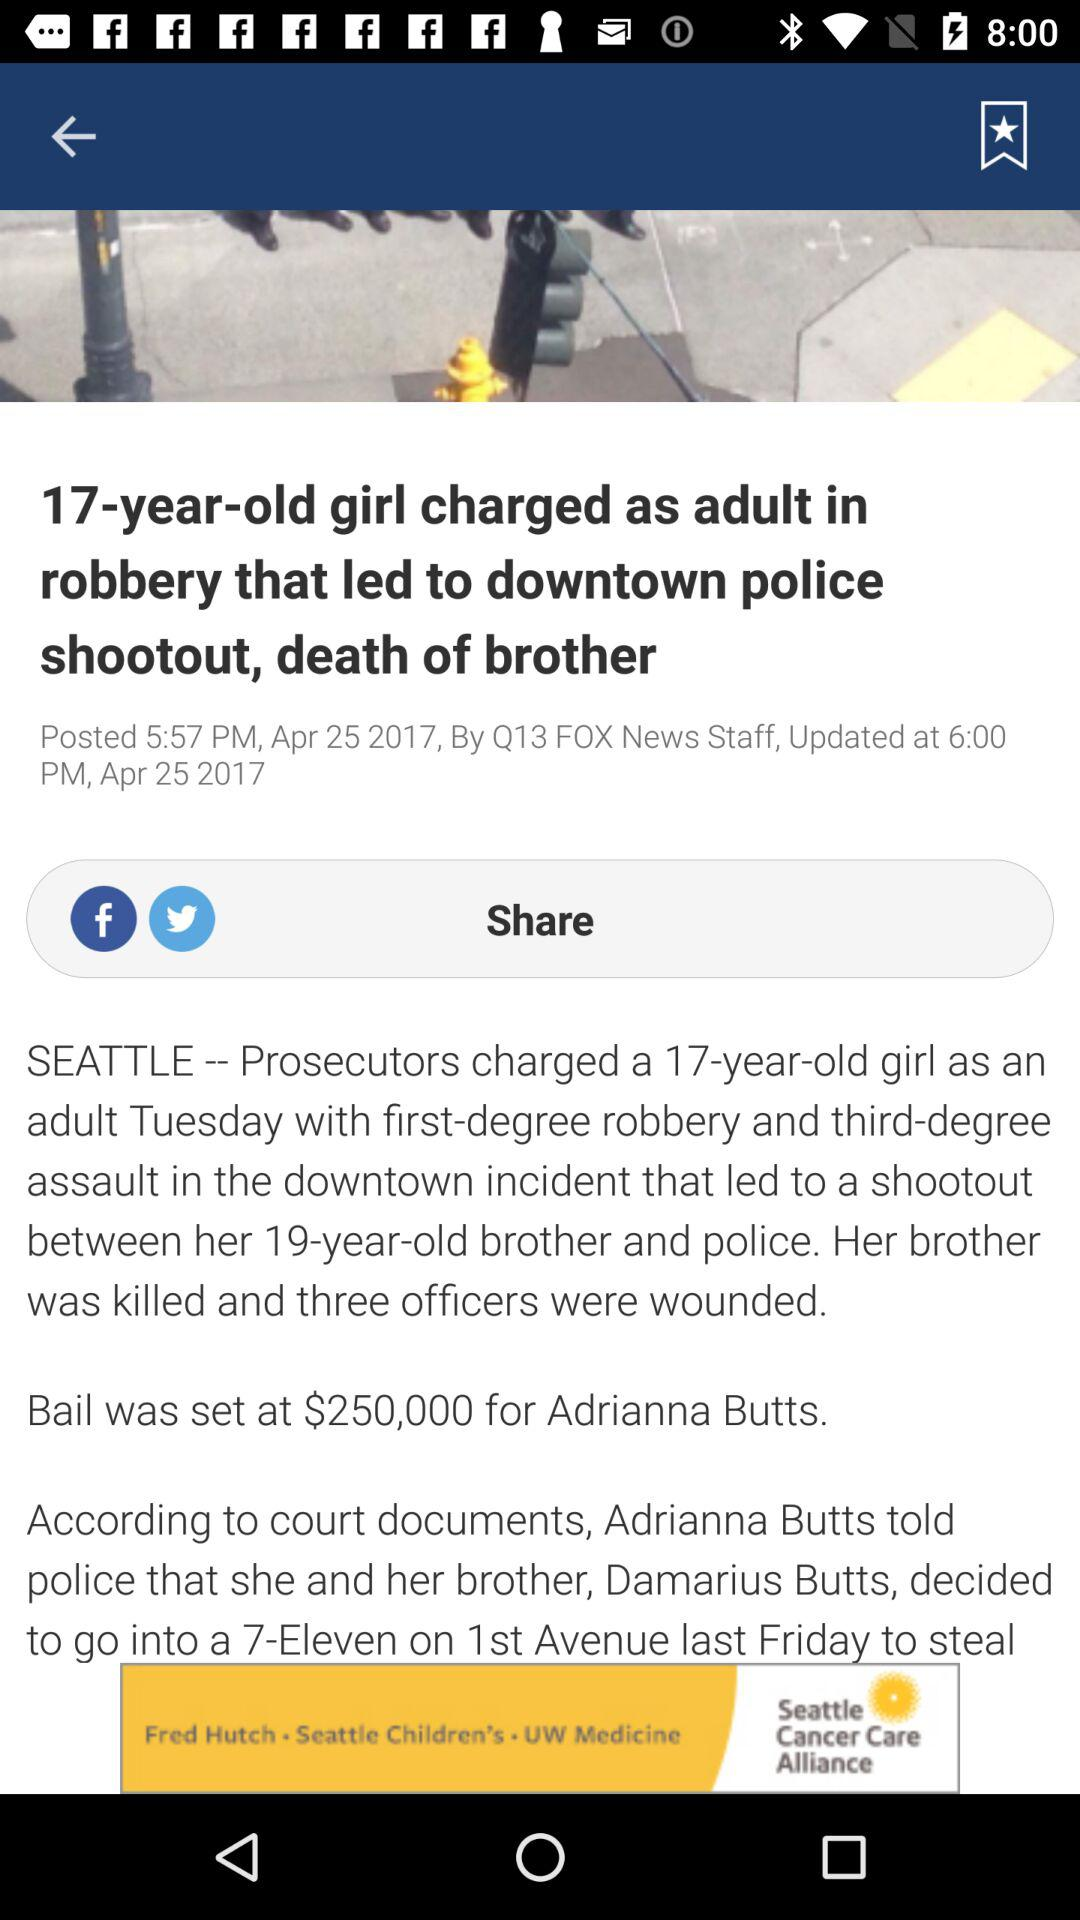What is the age of the girl who is charged with robbery? The age of the girl who is charged with robbery is 17 years. 